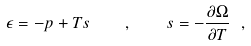<formula> <loc_0><loc_0><loc_500><loc_500>\epsilon = - p + T s \quad , \quad s = - \frac { \partial \Omega } { \partial T } \ ,</formula> 